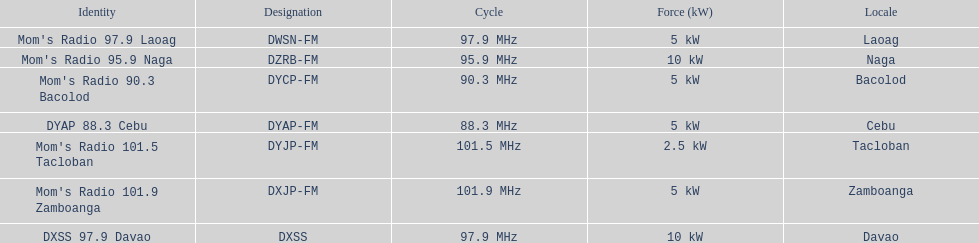Which of these stations broadcasts with the least power? Mom's Radio 101.5 Tacloban. 